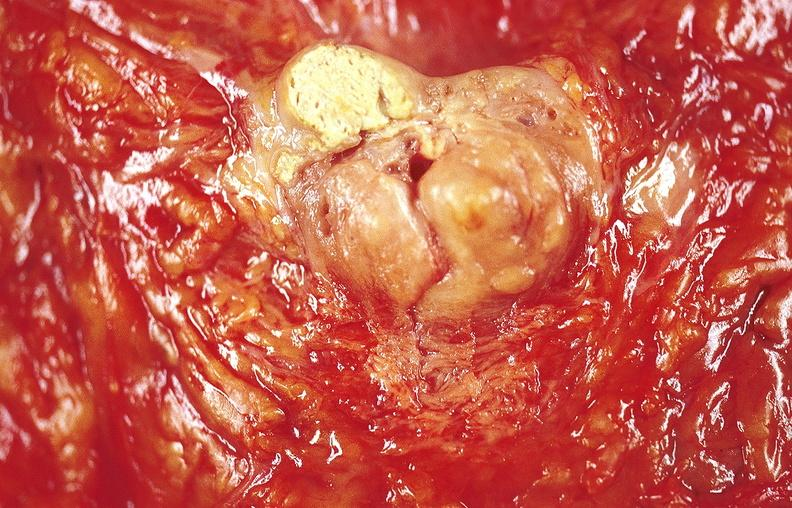does this image show gastric ulcer?
Answer the question using a single word or phrase. Yes 